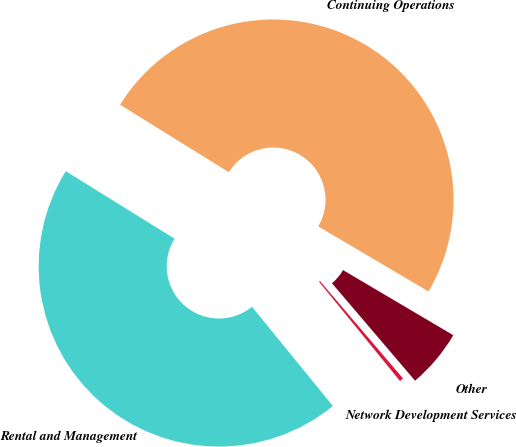Convert chart. <chart><loc_0><loc_0><loc_500><loc_500><pie_chart><fcel>Rental and Management<fcel>Network Development Services<fcel>Other<fcel>Continuing Operations<nl><fcel>44.73%<fcel>0.35%<fcel>5.27%<fcel>49.65%<nl></chart> 